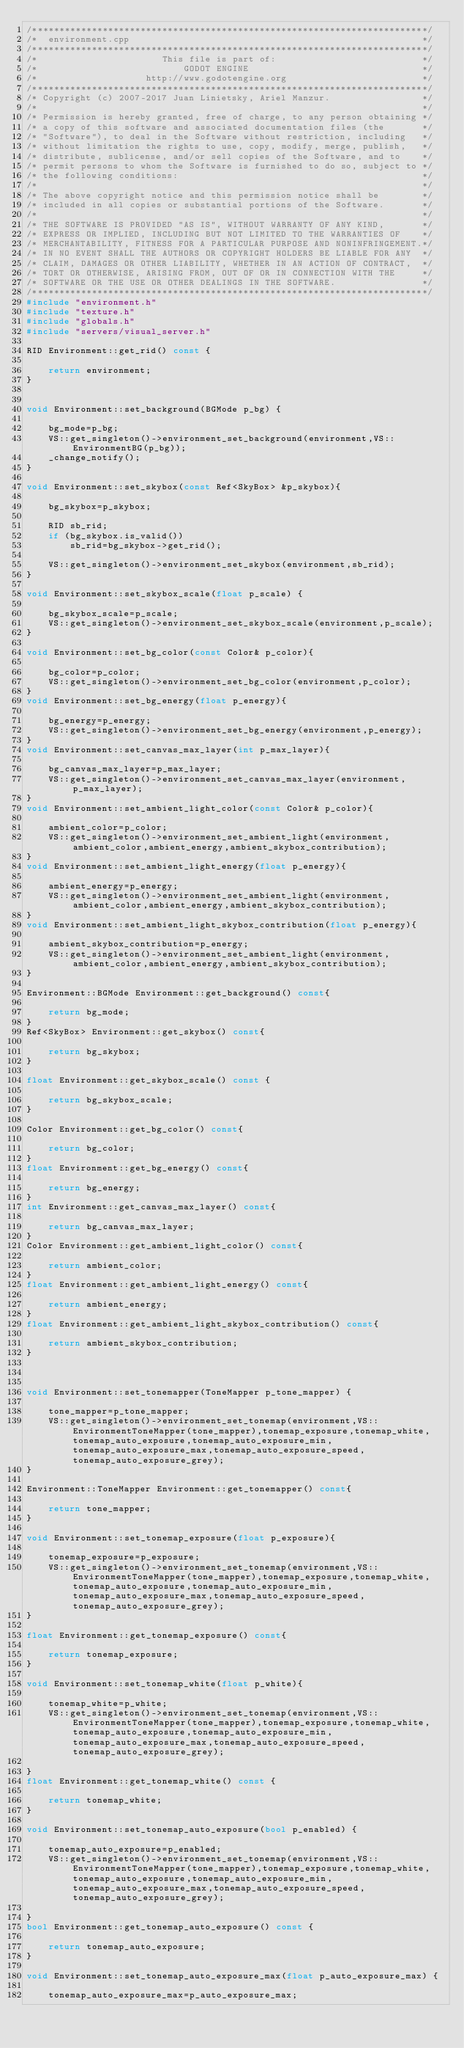<code> <loc_0><loc_0><loc_500><loc_500><_C++_>/*************************************************************************/
/*  environment.cpp                                                      */
/*************************************************************************/
/*                       This file is part of:                           */
/*                           GODOT ENGINE                                */
/*                    http://www.godotengine.org                         */
/*************************************************************************/
/* Copyright (c) 2007-2017 Juan Linietsky, Ariel Manzur.                 */
/*                                                                       */
/* Permission is hereby granted, free of charge, to any person obtaining */
/* a copy of this software and associated documentation files (the       */
/* "Software"), to deal in the Software without restriction, including   */
/* without limitation the rights to use, copy, modify, merge, publish,   */
/* distribute, sublicense, and/or sell copies of the Software, and to    */
/* permit persons to whom the Software is furnished to do so, subject to */
/* the following conditions:                                             */
/*                                                                       */
/* The above copyright notice and this permission notice shall be        */
/* included in all copies or substantial portions of the Software.       */
/*                                                                       */
/* THE SOFTWARE IS PROVIDED "AS IS", WITHOUT WARRANTY OF ANY KIND,       */
/* EXPRESS OR IMPLIED, INCLUDING BUT NOT LIMITED TO THE WARRANTIES OF    */
/* MERCHANTABILITY, FITNESS FOR A PARTICULAR PURPOSE AND NONINFRINGEMENT.*/
/* IN NO EVENT SHALL THE AUTHORS OR COPYRIGHT HOLDERS BE LIABLE FOR ANY  */
/* CLAIM, DAMAGES OR OTHER LIABILITY, WHETHER IN AN ACTION OF CONTRACT,  */
/* TORT OR OTHERWISE, ARISING FROM, OUT OF OR IN CONNECTION WITH THE     */
/* SOFTWARE OR THE USE OR OTHER DEALINGS IN THE SOFTWARE.                */
/*************************************************************************/
#include "environment.h"
#include "texture.h"
#include "globals.h"
#include "servers/visual_server.h"

RID Environment::get_rid() const {

	return environment;
}


void Environment::set_background(BGMode p_bg) {

	bg_mode=p_bg;
	VS::get_singleton()->environment_set_background(environment,VS::EnvironmentBG(p_bg));
	_change_notify();
}

void Environment::set_skybox(const Ref<SkyBox> &p_skybox){

	bg_skybox=p_skybox;

	RID sb_rid;
	if (bg_skybox.is_valid())
		sb_rid=bg_skybox->get_rid();

	VS::get_singleton()->environment_set_skybox(environment,sb_rid);
}

void Environment::set_skybox_scale(float p_scale) {

	bg_skybox_scale=p_scale;
	VS::get_singleton()->environment_set_skybox_scale(environment,p_scale);
}

void Environment::set_bg_color(const Color& p_color){

	bg_color=p_color;
	VS::get_singleton()->environment_set_bg_color(environment,p_color);
}
void Environment::set_bg_energy(float p_energy){

	bg_energy=p_energy;
	VS::get_singleton()->environment_set_bg_energy(environment,p_energy);
}
void Environment::set_canvas_max_layer(int p_max_layer){

	bg_canvas_max_layer=p_max_layer;
	VS::get_singleton()->environment_set_canvas_max_layer(environment,p_max_layer);
}
void Environment::set_ambient_light_color(const Color& p_color){

	ambient_color=p_color;
	VS::get_singleton()->environment_set_ambient_light(environment,ambient_color,ambient_energy,ambient_skybox_contribution);
}
void Environment::set_ambient_light_energy(float p_energy){

	ambient_energy=p_energy;
	VS::get_singleton()->environment_set_ambient_light(environment,ambient_color,ambient_energy,ambient_skybox_contribution);
}
void Environment::set_ambient_light_skybox_contribution(float p_energy){

	ambient_skybox_contribution=p_energy;
	VS::get_singleton()->environment_set_ambient_light(environment,ambient_color,ambient_energy,ambient_skybox_contribution);
}

Environment::BGMode Environment::get_background() const{

	return bg_mode;
}
Ref<SkyBox> Environment::get_skybox() const{

	return bg_skybox;
}

float Environment::get_skybox_scale() const {

	return bg_skybox_scale;
}

Color Environment::get_bg_color() const{

	return bg_color;
}
float Environment::get_bg_energy() const{

	return bg_energy;
}
int Environment::get_canvas_max_layer() const{

	return bg_canvas_max_layer;
}
Color Environment::get_ambient_light_color() const{

	return ambient_color;
}
float Environment::get_ambient_light_energy() const{

	return ambient_energy;
}
float Environment::get_ambient_light_skybox_contribution() const{

	return ambient_skybox_contribution;
}



void Environment::set_tonemapper(ToneMapper p_tone_mapper) {

	tone_mapper=p_tone_mapper;
	VS::get_singleton()->environment_set_tonemap(environment,VS::EnvironmentToneMapper(tone_mapper),tonemap_exposure,tonemap_white,tonemap_auto_exposure,tonemap_auto_exposure_min,tonemap_auto_exposure_max,tonemap_auto_exposure_speed,tonemap_auto_exposure_grey);
}

Environment::ToneMapper Environment::get_tonemapper() const{

	return tone_mapper;
}

void Environment::set_tonemap_exposure(float p_exposure){

	tonemap_exposure=p_exposure;
	VS::get_singleton()->environment_set_tonemap(environment,VS::EnvironmentToneMapper(tone_mapper),tonemap_exposure,tonemap_white,tonemap_auto_exposure,tonemap_auto_exposure_min,tonemap_auto_exposure_max,tonemap_auto_exposure_speed,tonemap_auto_exposure_grey);
}

float Environment::get_tonemap_exposure() const{

	return tonemap_exposure;
}

void Environment::set_tonemap_white(float p_white){

	tonemap_white=p_white;
	VS::get_singleton()->environment_set_tonemap(environment,VS::EnvironmentToneMapper(tone_mapper),tonemap_exposure,tonemap_white,tonemap_auto_exposure,tonemap_auto_exposure_min,tonemap_auto_exposure_max,tonemap_auto_exposure_speed,tonemap_auto_exposure_grey);

}
float Environment::get_tonemap_white() const {

	return tonemap_white;
}

void Environment::set_tonemap_auto_exposure(bool p_enabled) {

	tonemap_auto_exposure=p_enabled;
	VS::get_singleton()->environment_set_tonemap(environment,VS::EnvironmentToneMapper(tone_mapper),tonemap_exposure,tonemap_white,tonemap_auto_exposure,tonemap_auto_exposure_min,tonemap_auto_exposure_max,tonemap_auto_exposure_speed,tonemap_auto_exposure_grey);

}
bool Environment::get_tonemap_auto_exposure() const {

	return tonemap_auto_exposure;
}

void Environment::set_tonemap_auto_exposure_max(float p_auto_exposure_max) {

	tonemap_auto_exposure_max=p_auto_exposure_max;</code> 